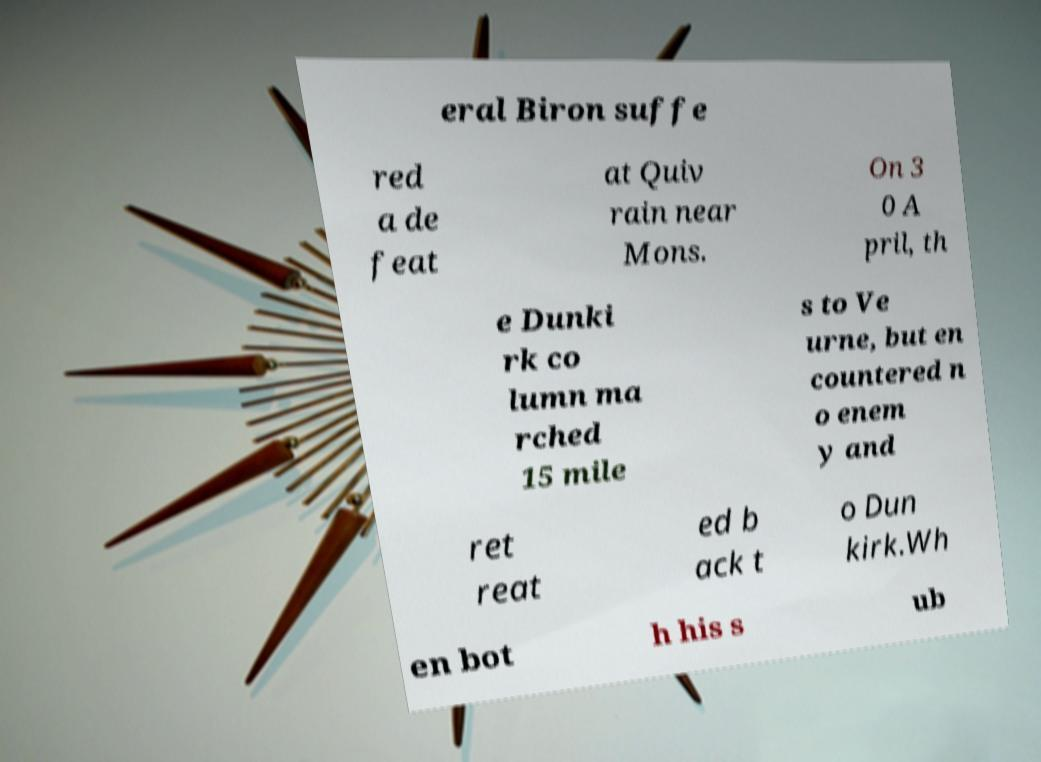Could you extract and type out the text from this image? eral Biron suffe red a de feat at Quiv rain near Mons. On 3 0 A pril, th e Dunki rk co lumn ma rched 15 mile s to Ve urne, but en countered n o enem y and ret reat ed b ack t o Dun kirk.Wh en bot h his s ub 